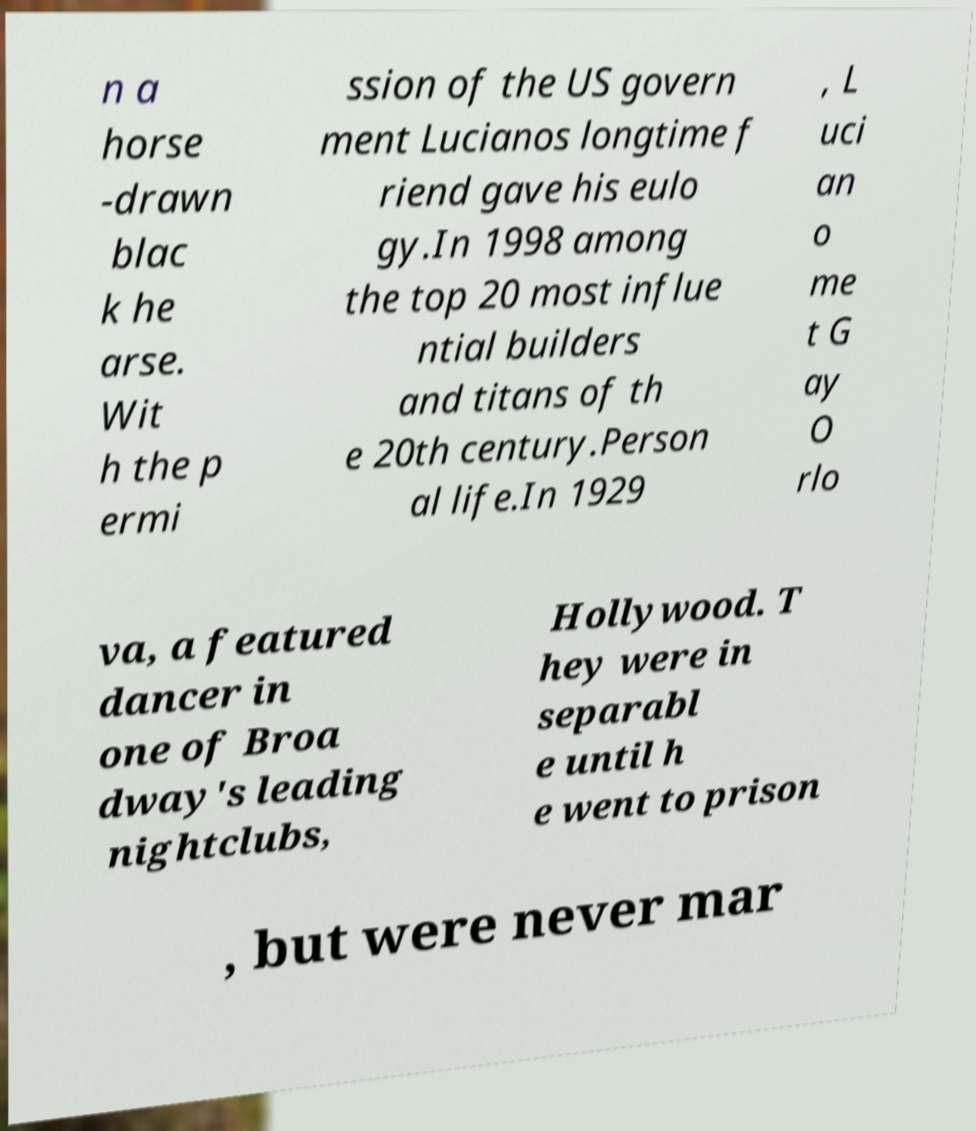What messages or text are displayed in this image? I need them in a readable, typed format. n a horse -drawn blac k he arse. Wit h the p ermi ssion of the US govern ment Lucianos longtime f riend gave his eulo gy.In 1998 among the top 20 most influe ntial builders and titans of th e 20th century.Person al life.In 1929 , L uci an o me t G ay O rlo va, a featured dancer in one of Broa dway's leading nightclubs, Hollywood. T hey were in separabl e until h e went to prison , but were never mar 